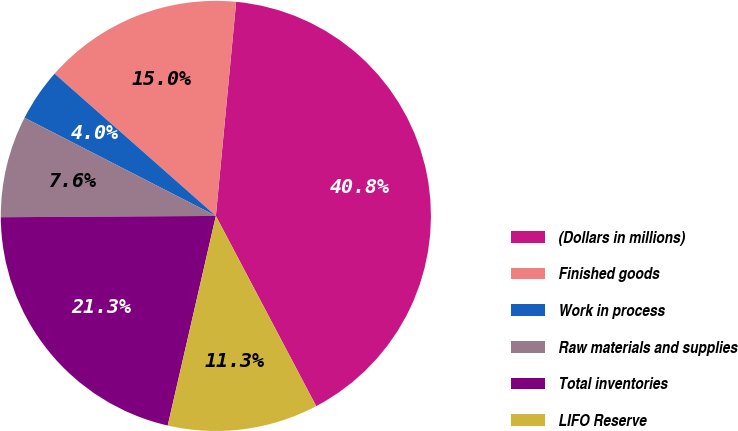<chart> <loc_0><loc_0><loc_500><loc_500><pie_chart><fcel>(Dollars in millions)<fcel>Finished goods<fcel>Work in process<fcel>Raw materials and supplies<fcel>Total inventories<fcel>LIFO Reserve<nl><fcel>40.77%<fcel>15.0%<fcel>3.96%<fcel>7.64%<fcel>21.31%<fcel>11.32%<nl></chart> 